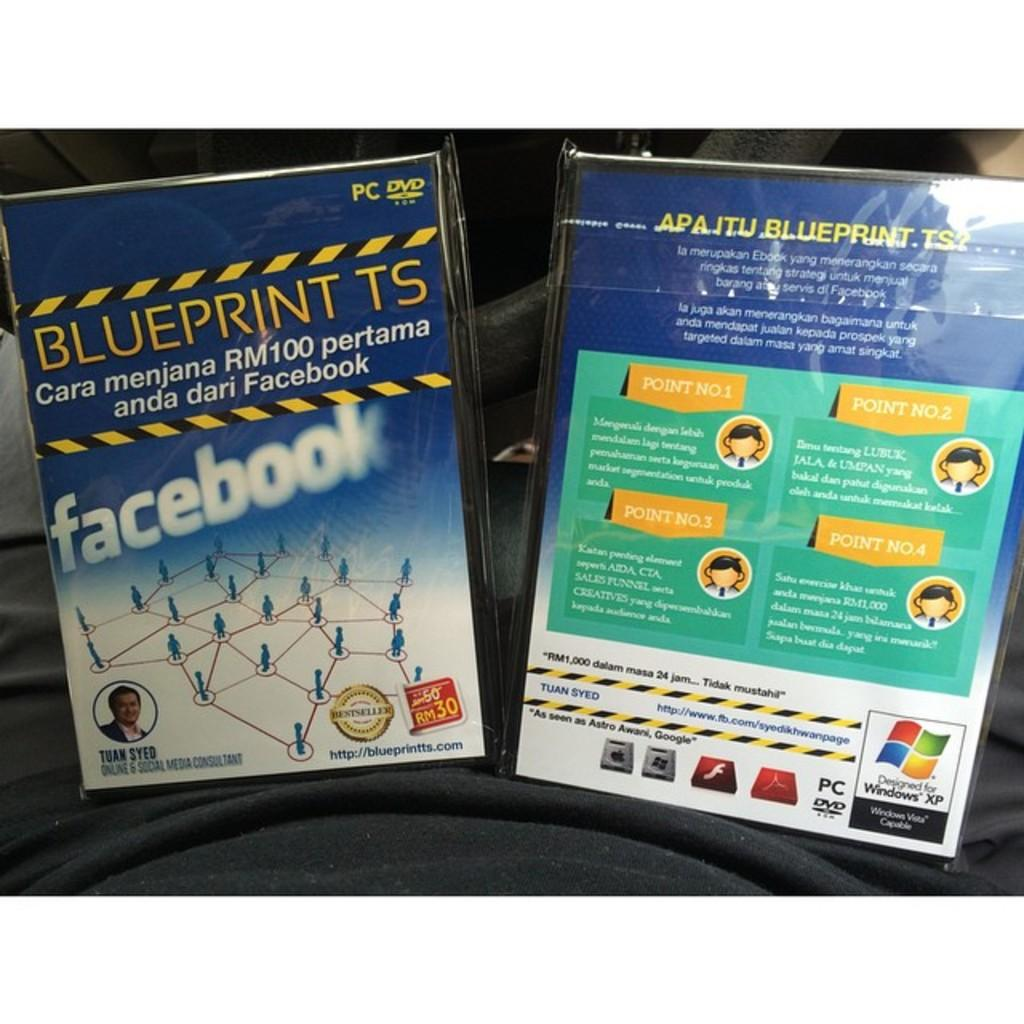<image>
Give a short and clear explanation of the subsequent image. A DVD for Blueprint TS was created by Tuan Syed, an online and social media consultant 